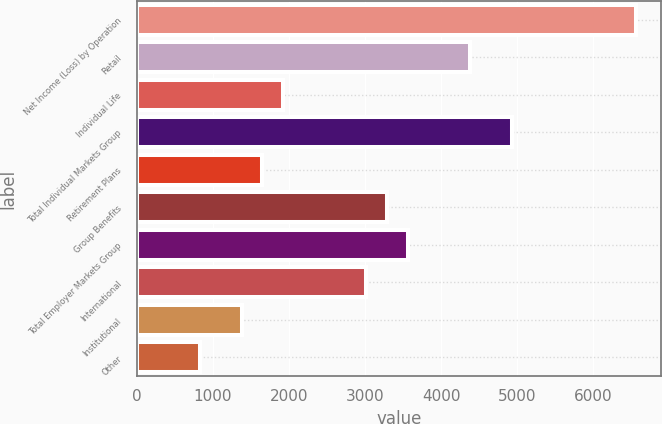<chart> <loc_0><loc_0><loc_500><loc_500><bar_chart><fcel>Net Income (Loss) by Operation<fcel>Retail<fcel>Individual Life<fcel>Total Individual Markets Group<fcel>Retirement Plans<fcel>Group Benefits<fcel>Total Employer Markets Group<fcel>International<fcel>Institutional<fcel>Other<nl><fcel>6564.2<fcel>4381.8<fcel>1926.6<fcel>4927.4<fcel>1653.8<fcel>3290.6<fcel>3563.4<fcel>3017.8<fcel>1381<fcel>835.4<nl></chart> 